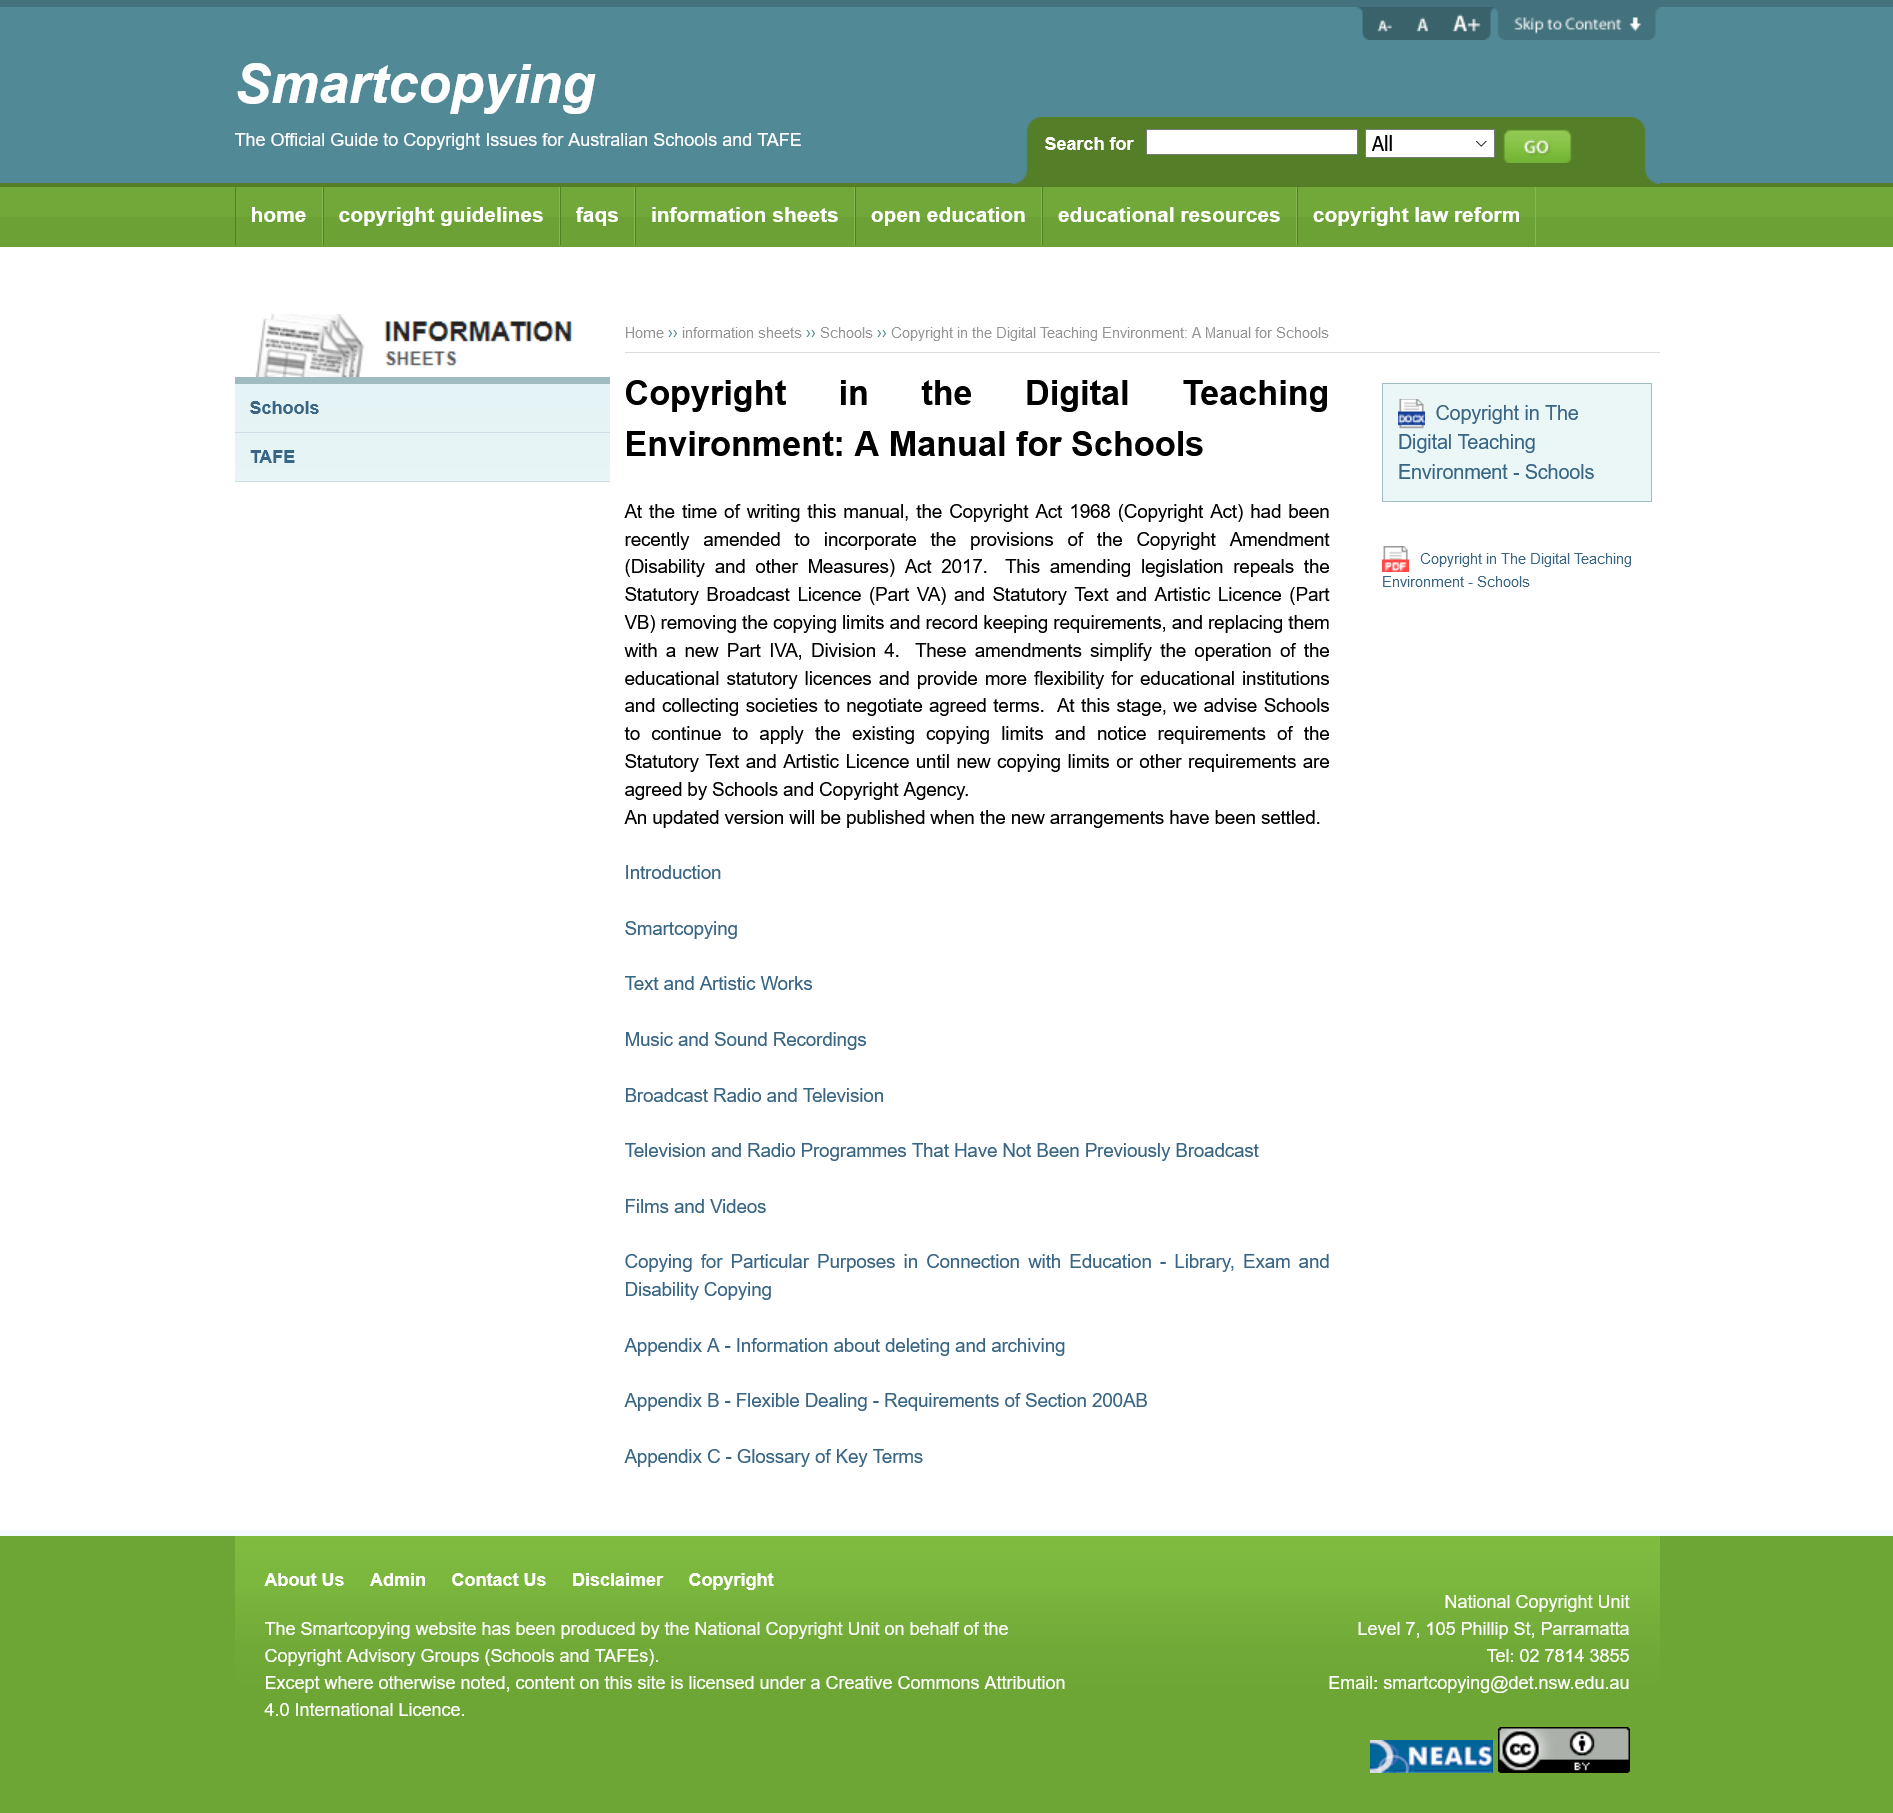Highlight a few significant elements in this photo. The title of this page is "Copyright in the Digital Teaching Environment: A Manual for Schools. This manual is intended for schools and is designed to provide guidance and support in the event of a lion breakout. The Copyright Act was published in 1968. 